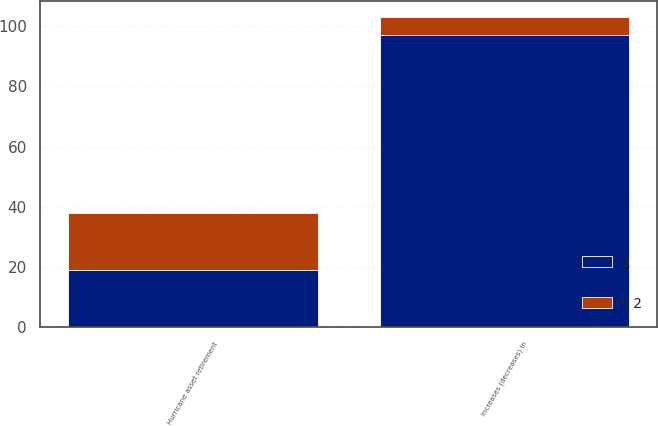Convert chart. <chart><loc_0><loc_0><loc_500><loc_500><stacked_bar_chart><ecel><fcel>Hurricane asset retirement<fcel>Increases (decreases) in<nl><fcel>9 2<fcel>19<fcel>6<nl><fcel>2<fcel>19<fcel>97<nl></chart> 